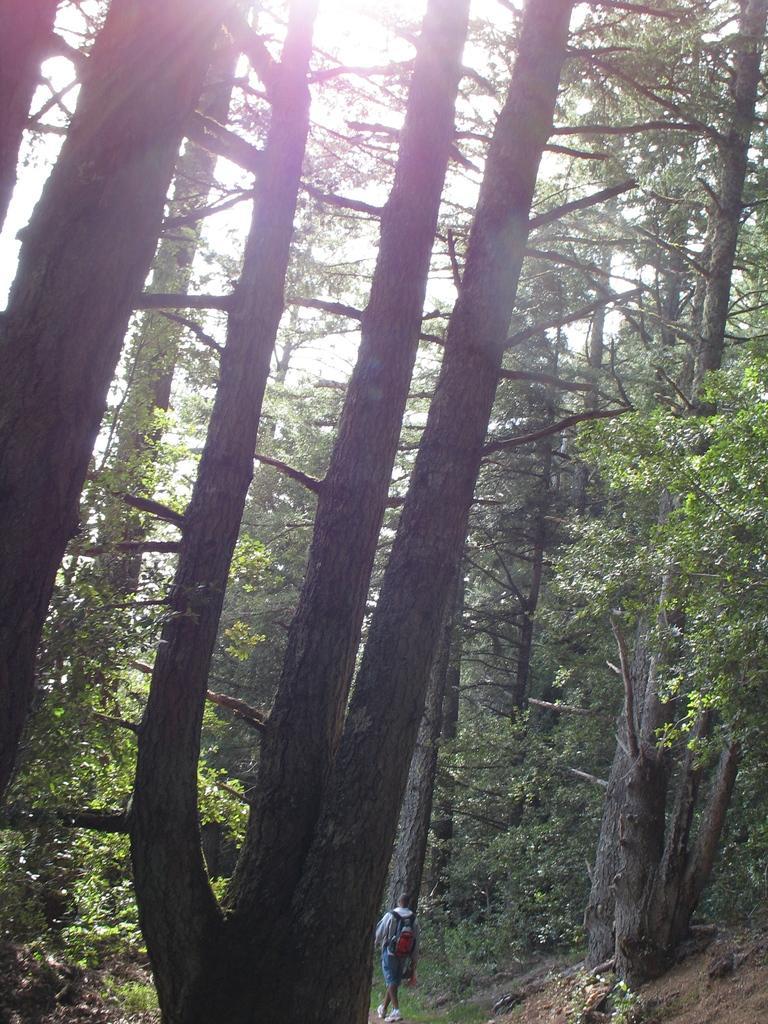Could you give a brief overview of what you see in this image? In this image we can see one person wearing a backpack and walking. There are some trees, plants and grass on the ground. At the top we can see the sunlight in the sky. 